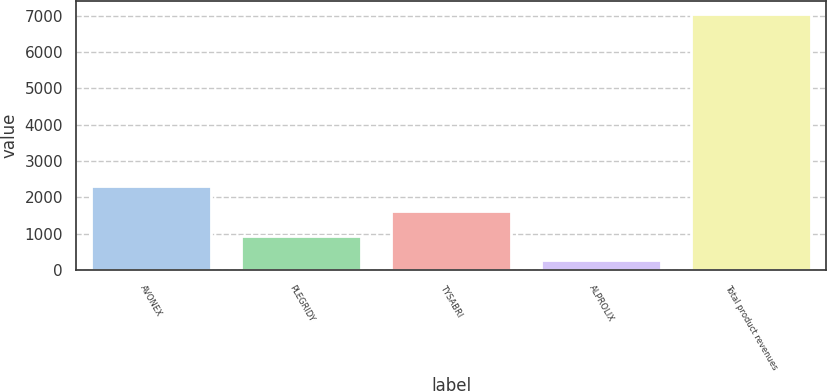Convert chart. <chart><loc_0><loc_0><loc_500><loc_500><bar_chart><fcel>AVONEX<fcel>PLEGRIDY<fcel>TYSABRI<fcel>ALPROLIX<fcel>Total product revenues<nl><fcel>2302.72<fcel>946.24<fcel>1624.48<fcel>268<fcel>7050.4<nl></chart> 